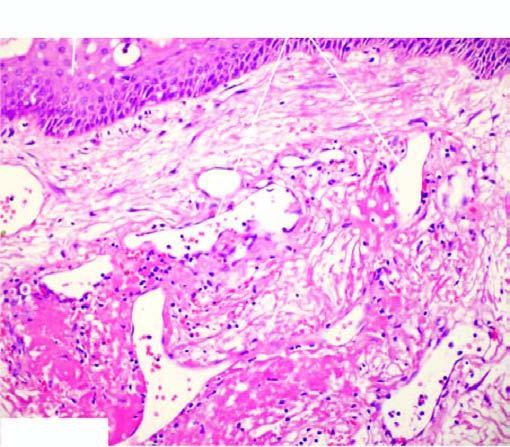does the lesion have intact surface epithelium?
Answer the question using a single word or phrase. Yes 